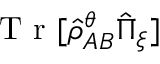<formula> <loc_0><loc_0><loc_500><loc_500>T r [ \hat { \rho } _ { A B } ^ { \theta } \hat { \Pi } _ { \xi } ]</formula> 